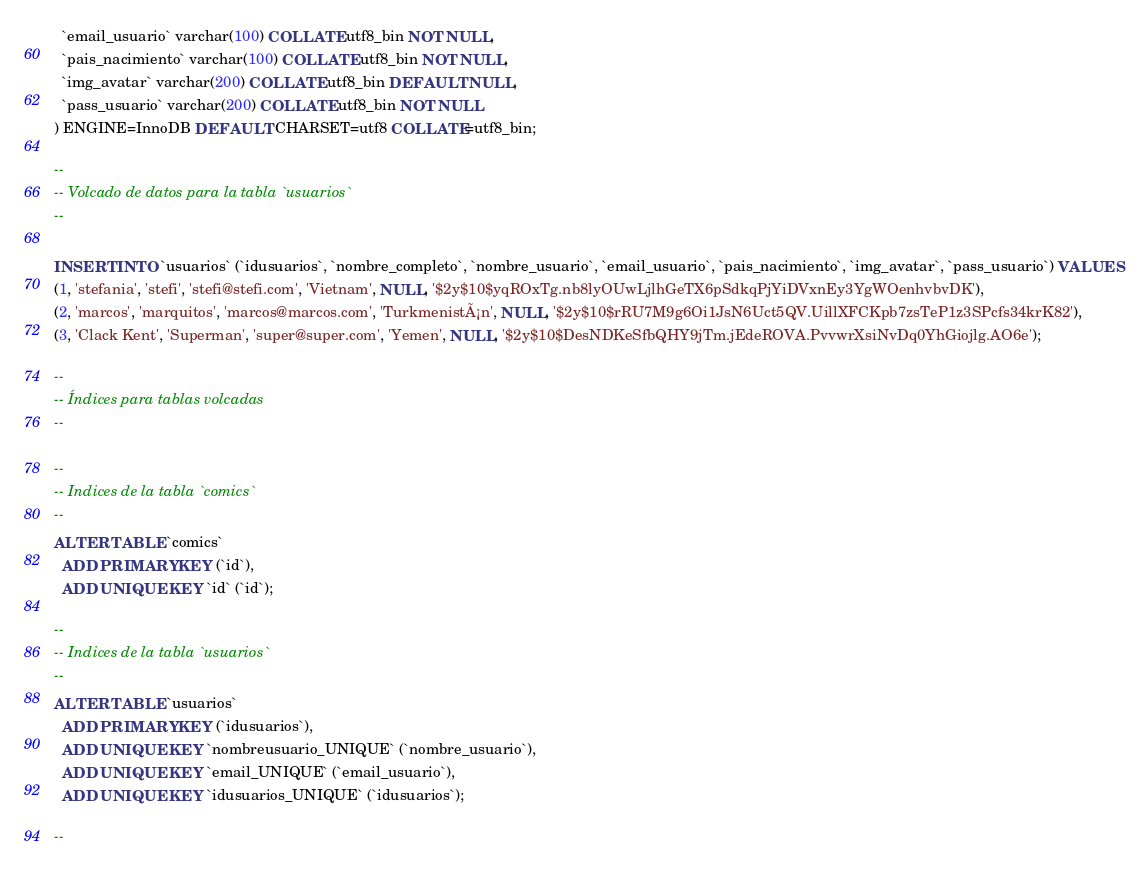Convert code to text. <code><loc_0><loc_0><loc_500><loc_500><_SQL_>  `email_usuario` varchar(100) COLLATE utf8_bin NOT NULL,
  `pais_nacimiento` varchar(100) COLLATE utf8_bin NOT NULL,
  `img_avatar` varchar(200) COLLATE utf8_bin DEFAULT NULL,
  `pass_usuario` varchar(200) COLLATE utf8_bin NOT NULL
) ENGINE=InnoDB DEFAULT CHARSET=utf8 COLLATE=utf8_bin;

--
-- Volcado de datos para la tabla `usuarios`
--

INSERT INTO `usuarios` (`idusuarios`, `nombre_completo`, `nombre_usuario`, `email_usuario`, `pais_nacimiento`, `img_avatar`, `pass_usuario`) VALUES
(1, 'stefania', 'stefi', 'stefi@stefi.com', 'Vietnam', NULL, '$2y$10$yqROxTg.nb8lyOUwLjlhGeTX6pSdkqPjYiDVxnEy3YgWOenhvbvDK'),
(2, 'marcos', 'marquitos', 'marcos@marcos.com', 'TurkmenistÃ¡n', NULL, '$2y$10$rRU7M9g6Oi1JsN6Uct5QV.UillXFCKpb7zsTeP1z3SPcfs34krK82'),
(3, 'Clack Kent', 'Superman', 'super@super.com', 'Yemen', NULL, '$2y$10$DesNDKeSfbQHY9jTm.jEdeROVA.PvvwrXsiNvDq0YhGiojlg.AO6e');

--
-- Índices para tablas volcadas
--

--
-- Indices de la tabla `comics`
--
ALTER TABLE `comics`
  ADD PRIMARY KEY (`id`),
  ADD UNIQUE KEY `id` (`id`);

--
-- Indices de la tabla `usuarios`
--
ALTER TABLE `usuarios`
  ADD PRIMARY KEY (`idusuarios`),
  ADD UNIQUE KEY `nombreusuario_UNIQUE` (`nombre_usuario`),
  ADD UNIQUE KEY `email_UNIQUE` (`email_usuario`),
  ADD UNIQUE KEY `idusuarios_UNIQUE` (`idusuarios`);

--</code> 